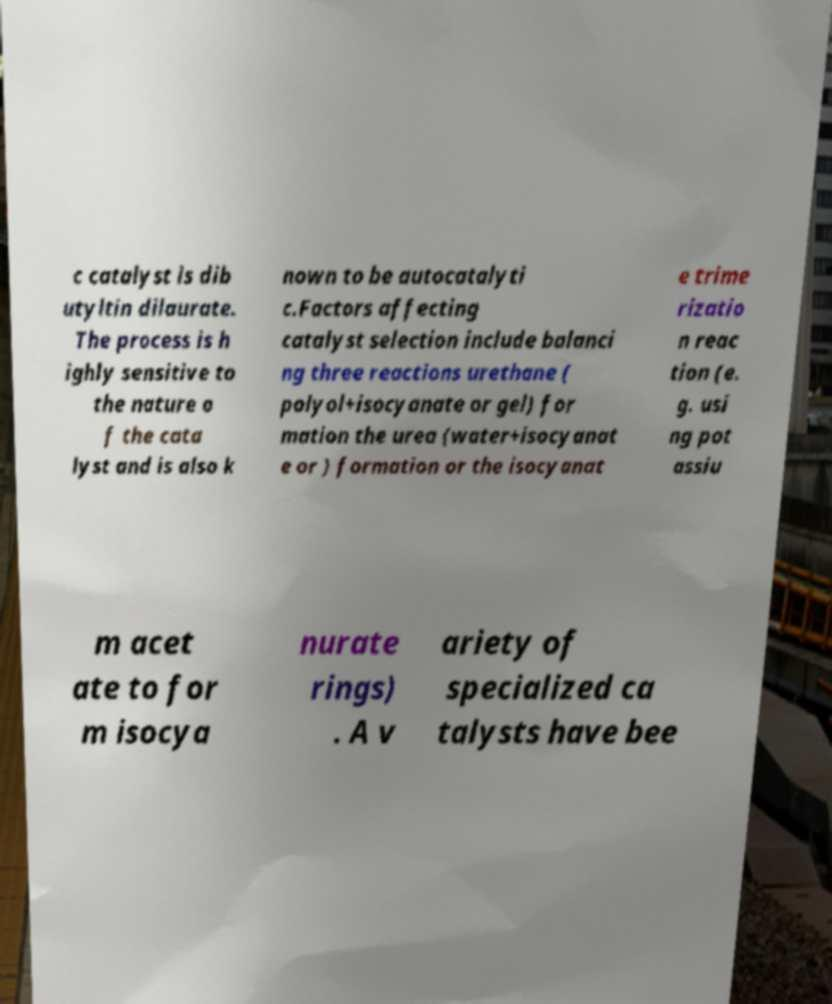Can you accurately transcribe the text from the provided image for me? c catalyst is dib utyltin dilaurate. The process is h ighly sensitive to the nature o f the cata lyst and is also k nown to be autocatalyti c.Factors affecting catalyst selection include balanci ng three reactions urethane ( polyol+isocyanate or gel) for mation the urea (water+isocyanat e or ) formation or the isocyanat e trime rizatio n reac tion (e. g. usi ng pot assiu m acet ate to for m isocya nurate rings) . A v ariety of specialized ca talysts have bee 